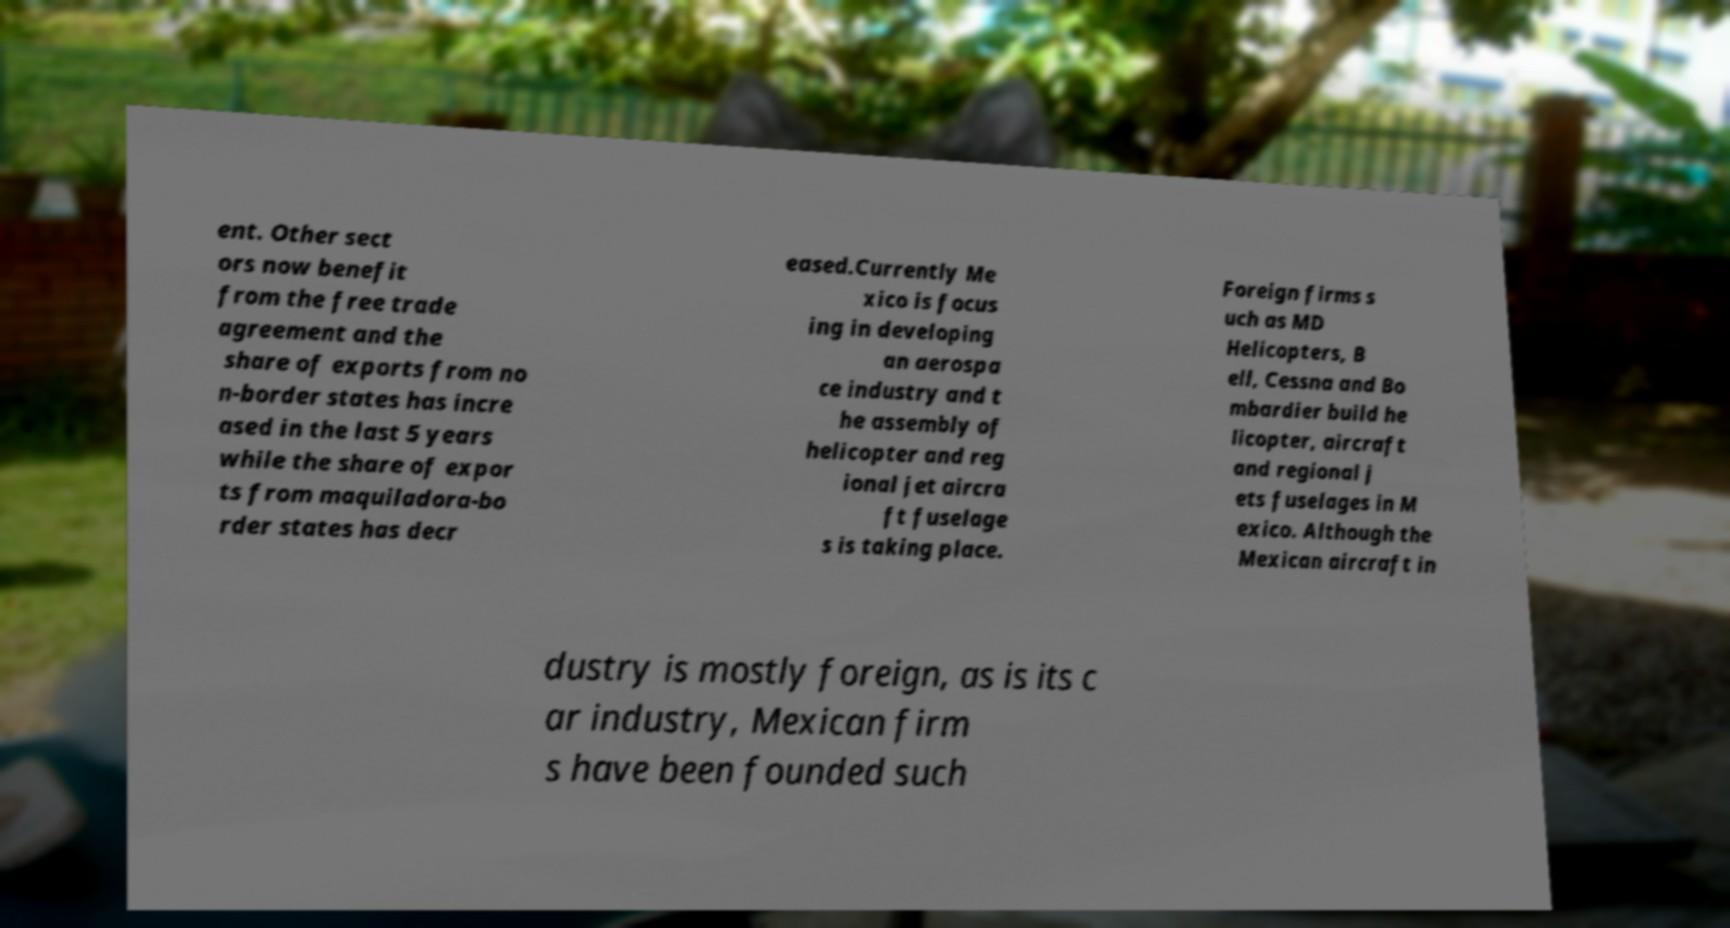I need the written content from this picture converted into text. Can you do that? ent. Other sect ors now benefit from the free trade agreement and the share of exports from no n-border states has incre ased in the last 5 years while the share of expor ts from maquiladora-bo rder states has decr eased.Currently Me xico is focus ing in developing an aerospa ce industry and t he assembly of helicopter and reg ional jet aircra ft fuselage s is taking place. Foreign firms s uch as MD Helicopters, B ell, Cessna and Bo mbardier build he licopter, aircraft and regional j ets fuselages in M exico. Although the Mexican aircraft in dustry is mostly foreign, as is its c ar industry, Mexican firm s have been founded such 